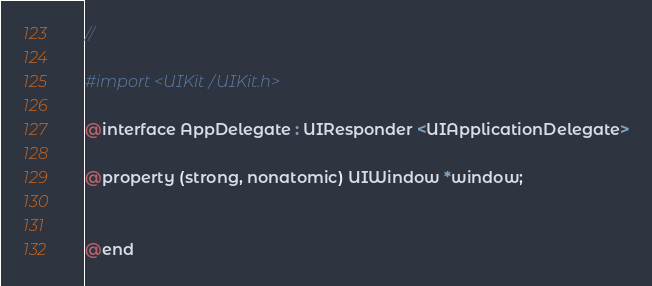Convert code to text. <code><loc_0><loc_0><loc_500><loc_500><_C_>//

#import <UIKit/UIKit.h>

@interface AppDelegate : UIResponder <UIApplicationDelegate>

@property (strong, nonatomic) UIWindow *window;


@end

</code> 